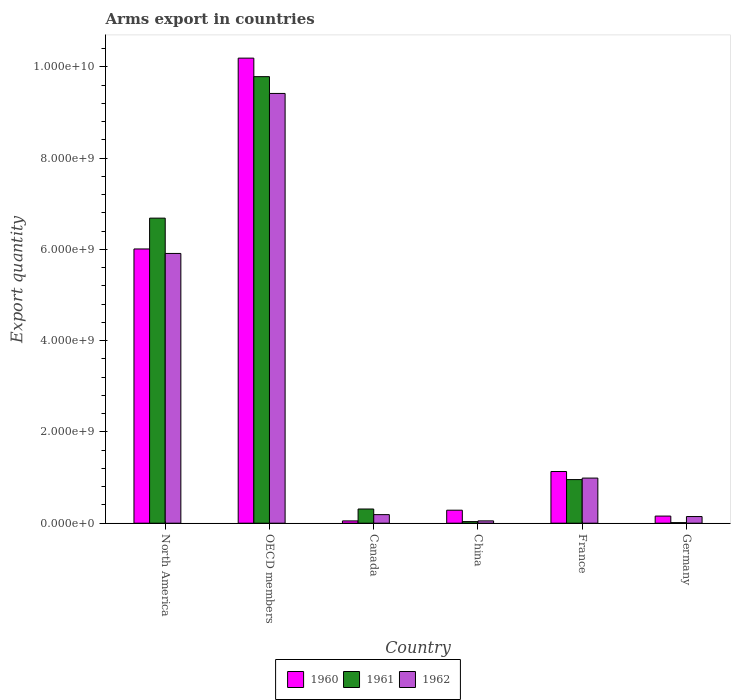How many bars are there on the 6th tick from the left?
Provide a succinct answer. 3. How many bars are there on the 4th tick from the right?
Give a very brief answer. 3. What is the total arms export in 1961 in China?
Your response must be concise. 3.50e+07. Across all countries, what is the maximum total arms export in 1962?
Ensure brevity in your answer.  9.42e+09. Across all countries, what is the minimum total arms export in 1961?
Provide a short and direct response. 1.20e+07. What is the total total arms export in 1961 in the graph?
Keep it short and to the point. 1.78e+1. What is the difference between the total arms export in 1962 in China and that in North America?
Provide a short and direct response. -5.86e+09. What is the difference between the total arms export in 1961 in Canada and the total arms export in 1960 in China?
Ensure brevity in your answer.  2.60e+07. What is the average total arms export in 1961 per country?
Your answer should be very brief. 2.96e+09. What is the difference between the total arms export of/in 1961 and total arms export of/in 1962 in Germany?
Give a very brief answer. -1.34e+08. What is the ratio of the total arms export in 1962 in Canada to that in Germany?
Ensure brevity in your answer.  1.29. What is the difference between the highest and the second highest total arms export in 1961?
Your answer should be very brief. 8.83e+09. What is the difference between the highest and the lowest total arms export in 1962?
Your response must be concise. 9.37e+09. Is the sum of the total arms export in 1962 in Germany and OECD members greater than the maximum total arms export in 1961 across all countries?
Keep it short and to the point. No. What does the 2nd bar from the right in North America represents?
Your response must be concise. 1961. Are all the bars in the graph horizontal?
Make the answer very short. No. Are the values on the major ticks of Y-axis written in scientific E-notation?
Make the answer very short. Yes. Does the graph contain any zero values?
Offer a very short reply. No. Does the graph contain grids?
Offer a very short reply. No. How many legend labels are there?
Offer a terse response. 3. What is the title of the graph?
Your answer should be compact. Arms export in countries. Does "2010" appear as one of the legend labels in the graph?
Give a very brief answer. No. What is the label or title of the Y-axis?
Provide a short and direct response. Export quantity. What is the Export quantity in 1960 in North America?
Keep it short and to the point. 6.01e+09. What is the Export quantity in 1961 in North America?
Your response must be concise. 6.69e+09. What is the Export quantity of 1962 in North America?
Make the answer very short. 5.91e+09. What is the Export quantity of 1960 in OECD members?
Keep it short and to the point. 1.02e+1. What is the Export quantity in 1961 in OECD members?
Offer a terse response. 9.79e+09. What is the Export quantity in 1962 in OECD members?
Offer a very short reply. 9.42e+09. What is the Export quantity of 1960 in Canada?
Ensure brevity in your answer.  5.00e+07. What is the Export quantity of 1961 in Canada?
Make the answer very short. 3.11e+08. What is the Export quantity in 1962 in Canada?
Provide a succinct answer. 1.88e+08. What is the Export quantity in 1960 in China?
Provide a succinct answer. 2.85e+08. What is the Export quantity of 1961 in China?
Your answer should be compact. 3.50e+07. What is the Export quantity of 1962 in China?
Ensure brevity in your answer.  5.10e+07. What is the Export quantity in 1960 in France?
Provide a short and direct response. 1.13e+09. What is the Export quantity of 1961 in France?
Offer a very short reply. 9.56e+08. What is the Export quantity in 1962 in France?
Make the answer very short. 9.89e+08. What is the Export quantity in 1960 in Germany?
Offer a very short reply. 1.56e+08. What is the Export quantity in 1962 in Germany?
Your answer should be compact. 1.46e+08. Across all countries, what is the maximum Export quantity in 1960?
Ensure brevity in your answer.  1.02e+1. Across all countries, what is the maximum Export quantity of 1961?
Offer a terse response. 9.79e+09. Across all countries, what is the maximum Export quantity of 1962?
Provide a succinct answer. 9.42e+09. Across all countries, what is the minimum Export quantity of 1960?
Make the answer very short. 5.00e+07. Across all countries, what is the minimum Export quantity in 1961?
Give a very brief answer. 1.20e+07. Across all countries, what is the minimum Export quantity of 1962?
Make the answer very short. 5.10e+07. What is the total Export quantity in 1960 in the graph?
Your response must be concise. 1.78e+1. What is the total Export quantity of 1961 in the graph?
Provide a succinct answer. 1.78e+1. What is the total Export quantity in 1962 in the graph?
Provide a succinct answer. 1.67e+1. What is the difference between the Export quantity in 1960 in North America and that in OECD members?
Your answer should be very brief. -4.18e+09. What is the difference between the Export quantity in 1961 in North America and that in OECD members?
Offer a very short reply. -3.10e+09. What is the difference between the Export quantity in 1962 in North America and that in OECD members?
Your response must be concise. -3.51e+09. What is the difference between the Export quantity of 1960 in North America and that in Canada?
Your response must be concise. 5.96e+09. What is the difference between the Export quantity in 1961 in North America and that in Canada?
Offer a very short reply. 6.38e+09. What is the difference between the Export quantity of 1962 in North America and that in Canada?
Provide a short and direct response. 5.72e+09. What is the difference between the Export quantity in 1960 in North America and that in China?
Your response must be concise. 5.73e+09. What is the difference between the Export quantity of 1961 in North America and that in China?
Give a very brief answer. 6.65e+09. What is the difference between the Export quantity of 1962 in North America and that in China?
Your answer should be compact. 5.86e+09. What is the difference between the Export quantity in 1960 in North America and that in France?
Make the answer very short. 4.88e+09. What is the difference between the Export quantity in 1961 in North America and that in France?
Provide a succinct answer. 5.73e+09. What is the difference between the Export quantity in 1962 in North America and that in France?
Offer a very short reply. 4.92e+09. What is the difference between the Export quantity in 1960 in North America and that in Germany?
Your response must be concise. 5.86e+09. What is the difference between the Export quantity of 1961 in North America and that in Germany?
Offer a terse response. 6.68e+09. What is the difference between the Export quantity of 1962 in North America and that in Germany?
Make the answer very short. 5.77e+09. What is the difference between the Export quantity in 1960 in OECD members and that in Canada?
Keep it short and to the point. 1.01e+1. What is the difference between the Export quantity of 1961 in OECD members and that in Canada?
Provide a short and direct response. 9.48e+09. What is the difference between the Export quantity in 1962 in OECD members and that in Canada?
Keep it short and to the point. 9.23e+09. What is the difference between the Export quantity of 1960 in OECD members and that in China?
Provide a succinct answer. 9.91e+09. What is the difference between the Export quantity in 1961 in OECD members and that in China?
Offer a terse response. 9.75e+09. What is the difference between the Export quantity in 1962 in OECD members and that in China?
Your response must be concise. 9.37e+09. What is the difference between the Export quantity of 1960 in OECD members and that in France?
Keep it short and to the point. 9.06e+09. What is the difference between the Export quantity in 1961 in OECD members and that in France?
Provide a succinct answer. 8.83e+09. What is the difference between the Export quantity in 1962 in OECD members and that in France?
Keep it short and to the point. 8.43e+09. What is the difference between the Export quantity in 1960 in OECD members and that in Germany?
Offer a very short reply. 1.00e+1. What is the difference between the Export quantity of 1961 in OECD members and that in Germany?
Your response must be concise. 9.78e+09. What is the difference between the Export quantity in 1962 in OECD members and that in Germany?
Your answer should be very brief. 9.27e+09. What is the difference between the Export quantity in 1960 in Canada and that in China?
Offer a very short reply. -2.35e+08. What is the difference between the Export quantity of 1961 in Canada and that in China?
Offer a very short reply. 2.76e+08. What is the difference between the Export quantity of 1962 in Canada and that in China?
Provide a succinct answer. 1.37e+08. What is the difference between the Export quantity in 1960 in Canada and that in France?
Your response must be concise. -1.08e+09. What is the difference between the Export quantity of 1961 in Canada and that in France?
Your answer should be compact. -6.45e+08. What is the difference between the Export quantity of 1962 in Canada and that in France?
Give a very brief answer. -8.01e+08. What is the difference between the Export quantity in 1960 in Canada and that in Germany?
Provide a short and direct response. -1.06e+08. What is the difference between the Export quantity of 1961 in Canada and that in Germany?
Provide a succinct answer. 2.99e+08. What is the difference between the Export quantity in 1962 in Canada and that in Germany?
Give a very brief answer. 4.20e+07. What is the difference between the Export quantity of 1960 in China and that in France?
Your answer should be compact. -8.48e+08. What is the difference between the Export quantity of 1961 in China and that in France?
Make the answer very short. -9.21e+08. What is the difference between the Export quantity of 1962 in China and that in France?
Offer a very short reply. -9.38e+08. What is the difference between the Export quantity in 1960 in China and that in Germany?
Offer a very short reply. 1.29e+08. What is the difference between the Export quantity in 1961 in China and that in Germany?
Provide a short and direct response. 2.30e+07. What is the difference between the Export quantity in 1962 in China and that in Germany?
Make the answer very short. -9.50e+07. What is the difference between the Export quantity of 1960 in France and that in Germany?
Provide a short and direct response. 9.77e+08. What is the difference between the Export quantity of 1961 in France and that in Germany?
Give a very brief answer. 9.44e+08. What is the difference between the Export quantity in 1962 in France and that in Germany?
Provide a short and direct response. 8.43e+08. What is the difference between the Export quantity of 1960 in North America and the Export quantity of 1961 in OECD members?
Your answer should be very brief. -3.78e+09. What is the difference between the Export quantity in 1960 in North America and the Export quantity in 1962 in OECD members?
Give a very brief answer. -3.41e+09. What is the difference between the Export quantity of 1961 in North America and the Export quantity of 1962 in OECD members?
Your answer should be compact. -2.73e+09. What is the difference between the Export quantity in 1960 in North America and the Export quantity in 1961 in Canada?
Make the answer very short. 5.70e+09. What is the difference between the Export quantity in 1960 in North America and the Export quantity in 1962 in Canada?
Offer a very short reply. 5.82e+09. What is the difference between the Export quantity in 1961 in North America and the Export quantity in 1962 in Canada?
Offer a terse response. 6.50e+09. What is the difference between the Export quantity of 1960 in North America and the Export quantity of 1961 in China?
Offer a very short reply. 5.98e+09. What is the difference between the Export quantity in 1960 in North America and the Export quantity in 1962 in China?
Provide a short and direct response. 5.96e+09. What is the difference between the Export quantity of 1961 in North America and the Export quantity of 1962 in China?
Offer a terse response. 6.64e+09. What is the difference between the Export quantity of 1960 in North America and the Export quantity of 1961 in France?
Your answer should be compact. 5.06e+09. What is the difference between the Export quantity in 1960 in North America and the Export quantity in 1962 in France?
Provide a short and direct response. 5.02e+09. What is the difference between the Export quantity in 1961 in North America and the Export quantity in 1962 in France?
Your answer should be compact. 5.70e+09. What is the difference between the Export quantity of 1960 in North America and the Export quantity of 1961 in Germany?
Offer a very short reply. 6.00e+09. What is the difference between the Export quantity in 1960 in North America and the Export quantity in 1962 in Germany?
Make the answer very short. 5.86e+09. What is the difference between the Export quantity in 1961 in North America and the Export quantity in 1962 in Germany?
Your answer should be compact. 6.54e+09. What is the difference between the Export quantity of 1960 in OECD members and the Export quantity of 1961 in Canada?
Make the answer very short. 9.88e+09. What is the difference between the Export quantity in 1960 in OECD members and the Export quantity in 1962 in Canada?
Provide a succinct answer. 1.00e+1. What is the difference between the Export quantity in 1961 in OECD members and the Export quantity in 1962 in Canada?
Offer a very short reply. 9.60e+09. What is the difference between the Export quantity in 1960 in OECD members and the Export quantity in 1961 in China?
Offer a terse response. 1.02e+1. What is the difference between the Export quantity in 1960 in OECD members and the Export quantity in 1962 in China?
Provide a short and direct response. 1.01e+1. What is the difference between the Export quantity of 1961 in OECD members and the Export quantity of 1962 in China?
Provide a short and direct response. 9.74e+09. What is the difference between the Export quantity in 1960 in OECD members and the Export quantity in 1961 in France?
Offer a very short reply. 9.24e+09. What is the difference between the Export quantity of 1960 in OECD members and the Export quantity of 1962 in France?
Your response must be concise. 9.20e+09. What is the difference between the Export quantity in 1961 in OECD members and the Export quantity in 1962 in France?
Ensure brevity in your answer.  8.80e+09. What is the difference between the Export quantity of 1960 in OECD members and the Export quantity of 1961 in Germany?
Give a very brief answer. 1.02e+1. What is the difference between the Export quantity in 1960 in OECD members and the Export quantity in 1962 in Germany?
Your answer should be compact. 1.00e+1. What is the difference between the Export quantity of 1961 in OECD members and the Export quantity of 1962 in Germany?
Keep it short and to the point. 9.64e+09. What is the difference between the Export quantity in 1960 in Canada and the Export quantity in 1961 in China?
Make the answer very short. 1.50e+07. What is the difference between the Export quantity of 1960 in Canada and the Export quantity of 1962 in China?
Ensure brevity in your answer.  -1.00e+06. What is the difference between the Export quantity of 1961 in Canada and the Export quantity of 1962 in China?
Provide a short and direct response. 2.60e+08. What is the difference between the Export quantity of 1960 in Canada and the Export quantity of 1961 in France?
Your answer should be compact. -9.06e+08. What is the difference between the Export quantity in 1960 in Canada and the Export quantity in 1962 in France?
Provide a succinct answer. -9.39e+08. What is the difference between the Export quantity of 1961 in Canada and the Export quantity of 1962 in France?
Your response must be concise. -6.78e+08. What is the difference between the Export quantity in 1960 in Canada and the Export quantity in 1961 in Germany?
Your response must be concise. 3.80e+07. What is the difference between the Export quantity in 1960 in Canada and the Export quantity in 1962 in Germany?
Provide a succinct answer. -9.60e+07. What is the difference between the Export quantity of 1961 in Canada and the Export quantity of 1962 in Germany?
Keep it short and to the point. 1.65e+08. What is the difference between the Export quantity in 1960 in China and the Export quantity in 1961 in France?
Give a very brief answer. -6.71e+08. What is the difference between the Export quantity of 1960 in China and the Export quantity of 1962 in France?
Your answer should be compact. -7.04e+08. What is the difference between the Export quantity of 1961 in China and the Export quantity of 1962 in France?
Offer a terse response. -9.54e+08. What is the difference between the Export quantity of 1960 in China and the Export quantity of 1961 in Germany?
Offer a very short reply. 2.73e+08. What is the difference between the Export quantity in 1960 in China and the Export quantity in 1962 in Germany?
Ensure brevity in your answer.  1.39e+08. What is the difference between the Export quantity in 1961 in China and the Export quantity in 1962 in Germany?
Make the answer very short. -1.11e+08. What is the difference between the Export quantity in 1960 in France and the Export quantity in 1961 in Germany?
Ensure brevity in your answer.  1.12e+09. What is the difference between the Export quantity in 1960 in France and the Export quantity in 1962 in Germany?
Provide a succinct answer. 9.87e+08. What is the difference between the Export quantity of 1961 in France and the Export quantity of 1962 in Germany?
Offer a very short reply. 8.10e+08. What is the average Export quantity in 1960 per country?
Make the answer very short. 2.97e+09. What is the average Export quantity of 1961 per country?
Offer a terse response. 2.96e+09. What is the average Export quantity in 1962 per country?
Provide a succinct answer. 2.78e+09. What is the difference between the Export quantity of 1960 and Export quantity of 1961 in North America?
Ensure brevity in your answer.  -6.76e+08. What is the difference between the Export quantity of 1960 and Export quantity of 1962 in North America?
Give a very brief answer. 9.80e+07. What is the difference between the Export quantity in 1961 and Export quantity in 1962 in North America?
Keep it short and to the point. 7.74e+08. What is the difference between the Export quantity in 1960 and Export quantity in 1961 in OECD members?
Provide a succinct answer. 4.06e+08. What is the difference between the Export quantity of 1960 and Export quantity of 1962 in OECD members?
Your answer should be compact. 7.74e+08. What is the difference between the Export quantity of 1961 and Export quantity of 1962 in OECD members?
Your answer should be very brief. 3.68e+08. What is the difference between the Export quantity in 1960 and Export quantity in 1961 in Canada?
Offer a terse response. -2.61e+08. What is the difference between the Export quantity in 1960 and Export quantity in 1962 in Canada?
Give a very brief answer. -1.38e+08. What is the difference between the Export quantity of 1961 and Export quantity of 1962 in Canada?
Your response must be concise. 1.23e+08. What is the difference between the Export quantity in 1960 and Export quantity in 1961 in China?
Offer a very short reply. 2.50e+08. What is the difference between the Export quantity of 1960 and Export quantity of 1962 in China?
Your response must be concise. 2.34e+08. What is the difference between the Export quantity in 1961 and Export quantity in 1962 in China?
Offer a very short reply. -1.60e+07. What is the difference between the Export quantity of 1960 and Export quantity of 1961 in France?
Offer a terse response. 1.77e+08. What is the difference between the Export quantity in 1960 and Export quantity in 1962 in France?
Offer a very short reply. 1.44e+08. What is the difference between the Export quantity in 1961 and Export quantity in 1962 in France?
Keep it short and to the point. -3.30e+07. What is the difference between the Export quantity of 1960 and Export quantity of 1961 in Germany?
Provide a short and direct response. 1.44e+08. What is the difference between the Export quantity of 1960 and Export quantity of 1962 in Germany?
Keep it short and to the point. 1.00e+07. What is the difference between the Export quantity of 1961 and Export quantity of 1962 in Germany?
Your answer should be compact. -1.34e+08. What is the ratio of the Export quantity in 1960 in North America to that in OECD members?
Give a very brief answer. 0.59. What is the ratio of the Export quantity of 1961 in North America to that in OECD members?
Keep it short and to the point. 0.68. What is the ratio of the Export quantity in 1962 in North America to that in OECD members?
Provide a succinct answer. 0.63. What is the ratio of the Export quantity in 1960 in North America to that in Canada?
Offer a terse response. 120.22. What is the ratio of the Export quantity of 1961 in North America to that in Canada?
Ensure brevity in your answer.  21.5. What is the ratio of the Export quantity in 1962 in North America to that in Canada?
Provide a succinct answer. 31.45. What is the ratio of the Export quantity in 1960 in North America to that in China?
Give a very brief answer. 21.09. What is the ratio of the Export quantity in 1961 in North America to that in China?
Your answer should be very brief. 191.06. What is the ratio of the Export quantity of 1962 in North America to that in China?
Make the answer very short. 115.94. What is the ratio of the Export quantity in 1960 in North America to that in France?
Your answer should be compact. 5.31. What is the ratio of the Export quantity in 1961 in North America to that in France?
Offer a terse response. 6.99. What is the ratio of the Export quantity of 1962 in North America to that in France?
Offer a terse response. 5.98. What is the ratio of the Export quantity of 1960 in North America to that in Germany?
Keep it short and to the point. 38.53. What is the ratio of the Export quantity in 1961 in North America to that in Germany?
Make the answer very short. 557.25. What is the ratio of the Export quantity of 1962 in North America to that in Germany?
Keep it short and to the point. 40.5. What is the ratio of the Export quantity of 1960 in OECD members to that in Canada?
Your response must be concise. 203.88. What is the ratio of the Export quantity in 1961 in OECD members to that in Canada?
Offer a terse response. 31.47. What is the ratio of the Export quantity in 1962 in OECD members to that in Canada?
Provide a short and direct response. 50.11. What is the ratio of the Export quantity of 1960 in OECD members to that in China?
Your answer should be compact. 35.77. What is the ratio of the Export quantity in 1961 in OECD members to that in China?
Offer a terse response. 279.66. What is the ratio of the Export quantity in 1962 in OECD members to that in China?
Ensure brevity in your answer.  184.71. What is the ratio of the Export quantity of 1960 in OECD members to that in France?
Make the answer very short. 9. What is the ratio of the Export quantity in 1961 in OECD members to that in France?
Your response must be concise. 10.24. What is the ratio of the Export quantity of 1962 in OECD members to that in France?
Give a very brief answer. 9.52. What is the ratio of the Export quantity of 1960 in OECD members to that in Germany?
Ensure brevity in your answer.  65.35. What is the ratio of the Export quantity in 1961 in OECD members to that in Germany?
Provide a succinct answer. 815.67. What is the ratio of the Export quantity in 1962 in OECD members to that in Germany?
Offer a terse response. 64.52. What is the ratio of the Export quantity in 1960 in Canada to that in China?
Your response must be concise. 0.18. What is the ratio of the Export quantity of 1961 in Canada to that in China?
Offer a very short reply. 8.89. What is the ratio of the Export quantity in 1962 in Canada to that in China?
Give a very brief answer. 3.69. What is the ratio of the Export quantity in 1960 in Canada to that in France?
Your response must be concise. 0.04. What is the ratio of the Export quantity in 1961 in Canada to that in France?
Provide a succinct answer. 0.33. What is the ratio of the Export quantity in 1962 in Canada to that in France?
Offer a very short reply. 0.19. What is the ratio of the Export quantity of 1960 in Canada to that in Germany?
Your answer should be very brief. 0.32. What is the ratio of the Export quantity of 1961 in Canada to that in Germany?
Keep it short and to the point. 25.92. What is the ratio of the Export quantity of 1962 in Canada to that in Germany?
Your answer should be compact. 1.29. What is the ratio of the Export quantity in 1960 in China to that in France?
Your answer should be compact. 0.25. What is the ratio of the Export quantity of 1961 in China to that in France?
Keep it short and to the point. 0.04. What is the ratio of the Export quantity in 1962 in China to that in France?
Your answer should be very brief. 0.05. What is the ratio of the Export quantity in 1960 in China to that in Germany?
Give a very brief answer. 1.83. What is the ratio of the Export quantity of 1961 in China to that in Germany?
Give a very brief answer. 2.92. What is the ratio of the Export quantity in 1962 in China to that in Germany?
Your response must be concise. 0.35. What is the ratio of the Export quantity of 1960 in France to that in Germany?
Ensure brevity in your answer.  7.26. What is the ratio of the Export quantity of 1961 in France to that in Germany?
Keep it short and to the point. 79.67. What is the ratio of the Export quantity of 1962 in France to that in Germany?
Offer a very short reply. 6.77. What is the difference between the highest and the second highest Export quantity in 1960?
Your response must be concise. 4.18e+09. What is the difference between the highest and the second highest Export quantity of 1961?
Provide a succinct answer. 3.10e+09. What is the difference between the highest and the second highest Export quantity of 1962?
Your answer should be compact. 3.51e+09. What is the difference between the highest and the lowest Export quantity of 1960?
Ensure brevity in your answer.  1.01e+1. What is the difference between the highest and the lowest Export quantity of 1961?
Make the answer very short. 9.78e+09. What is the difference between the highest and the lowest Export quantity of 1962?
Offer a terse response. 9.37e+09. 